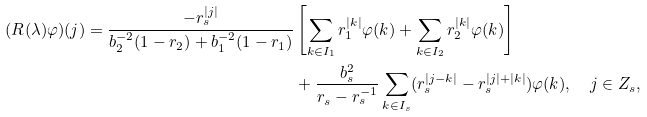<formula> <loc_0><loc_0><loc_500><loc_500>( R ( \lambda ) \varphi ) ( j ) = \frac { - r _ { s } ^ { | j | } } { b _ { 2 } ^ { - 2 } ( 1 - r _ { 2 } ) + b _ { 1 } ^ { - 2 } ( 1 - r _ { 1 } ) } & \left [ \sum _ { k \in I _ { 1 } } r _ { 1 } ^ { | k | } \varphi ( k ) + \sum _ { k \in I _ { 2 } } r _ { 2 } ^ { | k | } \varphi ( k ) \right ] \\ & + \frac { b _ { s } ^ { 2 } } { r _ { s } - r _ { s } ^ { - 1 } } \sum _ { k \in I _ { s } } ( r _ { s } ^ { | j - k | } - r _ { s } ^ { | j | + | k | } ) \varphi ( k ) , \quad j \in Z _ { s } ,</formula> 